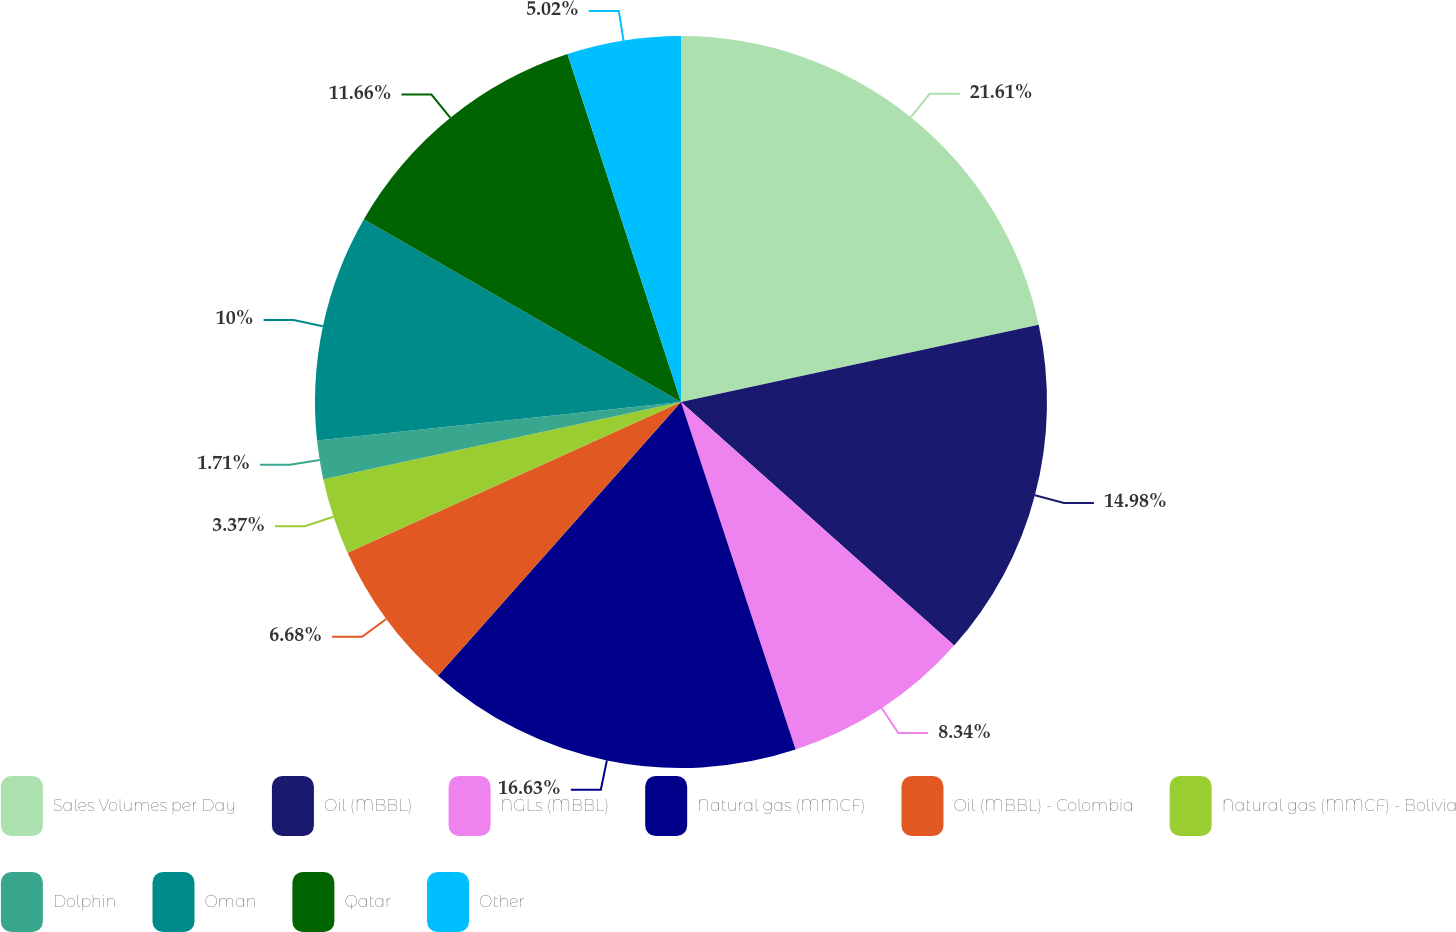Convert chart to OTSL. <chart><loc_0><loc_0><loc_500><loc_500><pie_chart><fcel>Sales Volumes per Day<fcel>Oil (MBBL)<fcel>NGLs (MBBL)<fcel>Natural gas (MMCF)<fcel>Oil (MBBL) - Colombia<fcel>Natural gas (MMCF) - Bolivia<fcel>Dolphin<fcel>Oman<fcel>Qatar<fcel>Other<nl><fcel>21.61%<fcel>14.98%<fcel>8.34%<fcel>16.63%<fcel>6.68%<fcel>3.37%<fcel>1.71%<fcel>10.0%<fcel>11.66%<fcel>5.02%<nl></chart> 